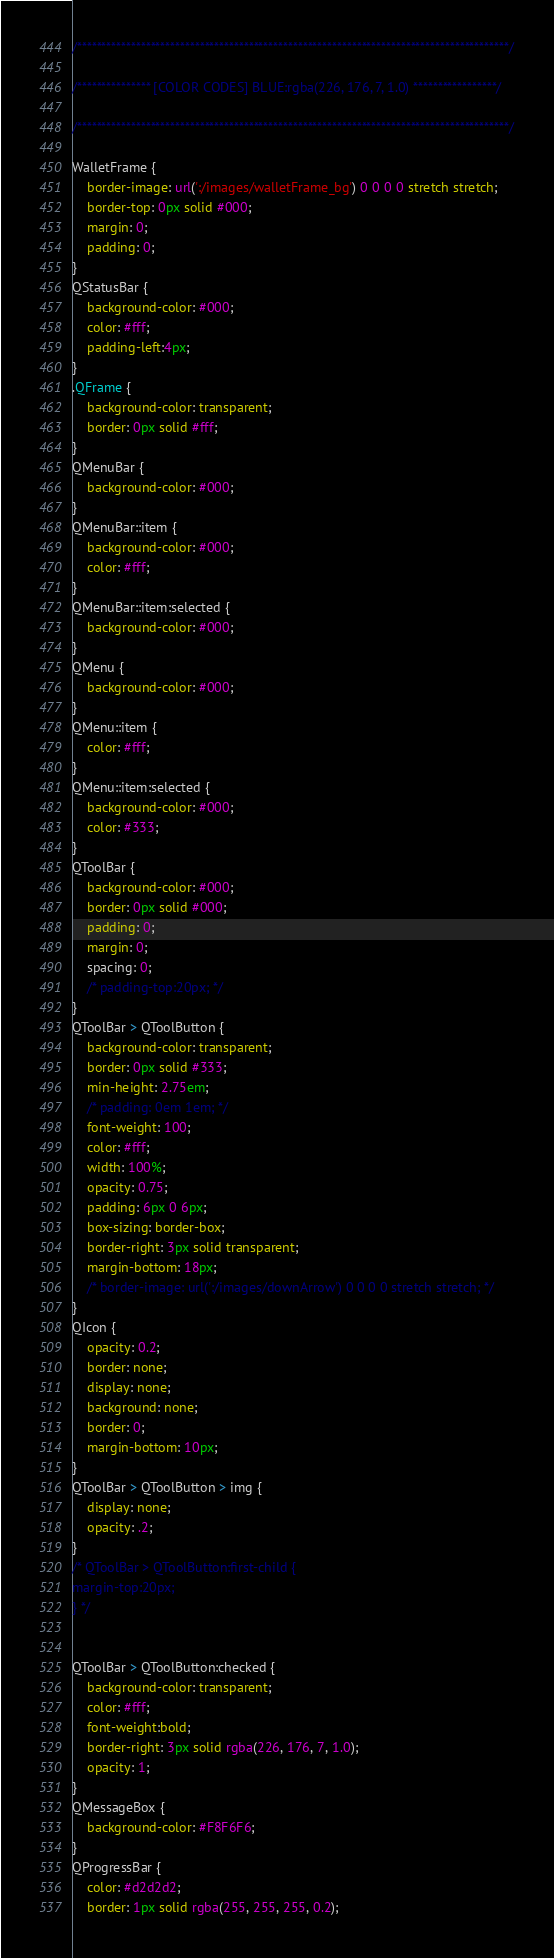Convert code to text. <code><loc_0><loc_0><loc_500><loc_500><_CSS_>/****************************************************************************************/

/*************** [COLOR CODES] BLUE:rgba(226, 176, 7, 1.0) *****************/

/****************************************************************************************/

WalletFrame {
	border-image: url(':/images/walletFrame_bg') 0 0 0 0 stretch stretch;
	border-top: 0px solid #000;
	margin: 0;
	padding: 0;
}
QStatusBar {
    background-color: #000;
    color: #fff;
    padding-left:4px;
}
.QFrame {
	background-color: transparent;
	border: 0px solid #fff;
}
QMenuBar {
	background-color: #000;
}
QMenuBar::item {
	background-color: #000;
	color: #fff;
}
QMenuBar::item:selected {
	background-color: #000;
}
QMenu {
	background-color: #000;
}
QMenu::item {
	color: #fff;
}
QMenu::item:selected {
	background-color: #000;
	color: #333;
}
QToolBar {
	background-color: #000;
	border: 0px solid #000;
	padding: 0;
	margin: 0;
	spacing: 0;
	/* padding-top:20px; */
}
QToolBar > QToolButton {
	background-color: transparent;
	border: 0px solid #333;
	min-height: 2.75em;
	/* padding: 0em 1em; */
	font-weight: 100;
	color: #fff;
	width: 100%;
	opacity: 0.75;
	padding: 6px 0 6px;
	box-sizing: border-box;
	border-right: 3px solid transparent;
	margin-bottom: 18px;
	/* border-image: url(':/images/downArrow') 0 0 0 0 stretch stretch; */
}
QIcon {
	opacity: 0.2;
	border: none;
	display: none;
	background: none;
	border: 0;
	margin-bottom: 10px;
}
QToolBar > QToolButton > img {
	display: none;
	opacity: .2;
}
/* QToolBar > QToolButton:first-child {
margin-top:20px;
} */


QToolBar > QToolButton:checked {
	background-color: transparent;
	color: #fff;
	font-weight:bold;
	border-right: 3px solid rgba(226, 176, 7, 1.0);
	opacity: 1;
}
QMessageBox {
	background-color: #F8F6F6;
}
QProgressBar {
	color: #d2d2d2;
	border: 1px solid rgba(255, 255, 255, 0.2);</code> 